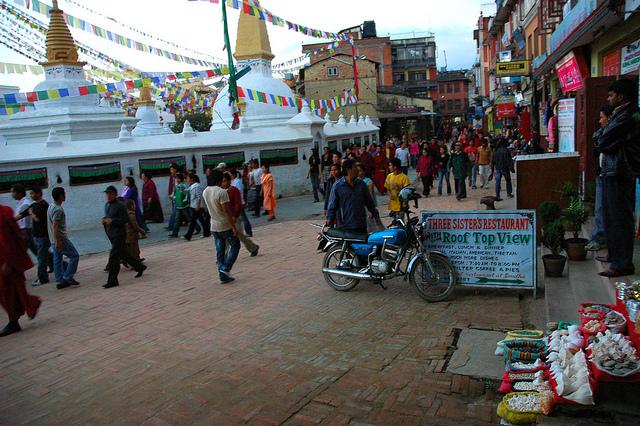What are all the overhead wires for?
Be succinct. Decoration. Is this a quiet street?
Quick response, please. No. How many steps are there on the right?
Short answer required. 3. What kind of banners and flags are being held up?
Quick response, please. Colorful. What type of transportation is in view?
Quick response, please. Motorcycle. Are there banners hanging from the buildings?
Short answer required. Yes. 